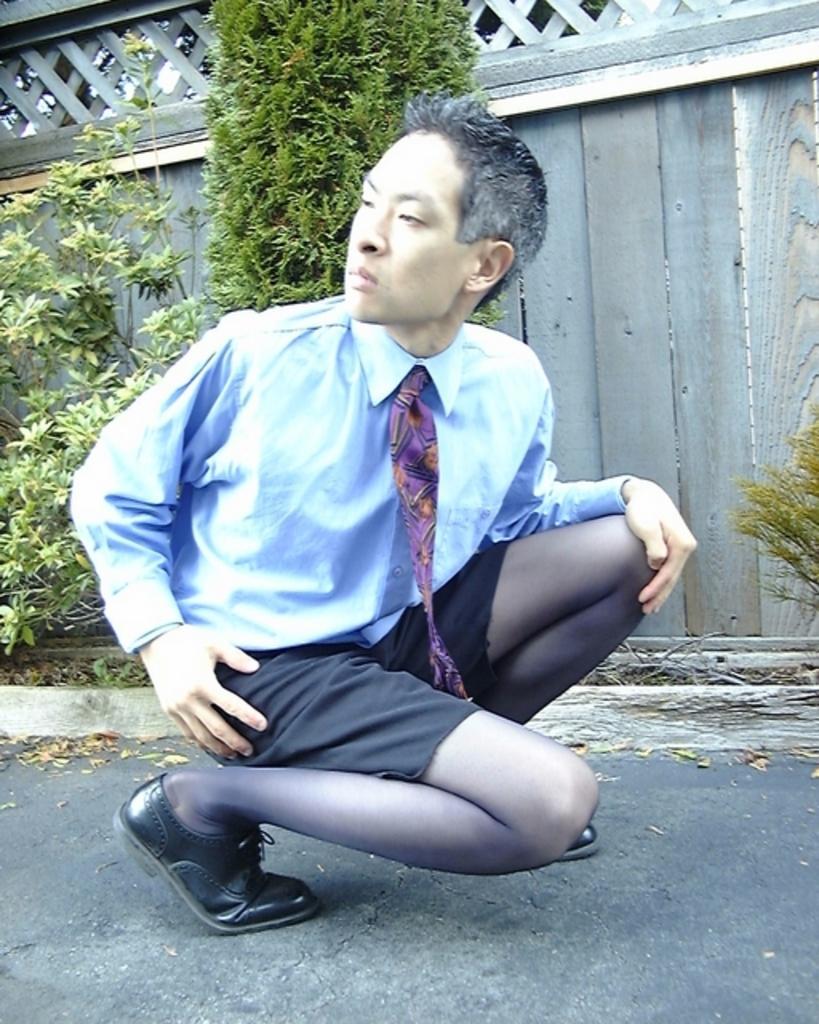Can you describe this image briefly? In this image I can see a person. The person wearing white shirt, black short, background I can see a house, and trees in green color. 